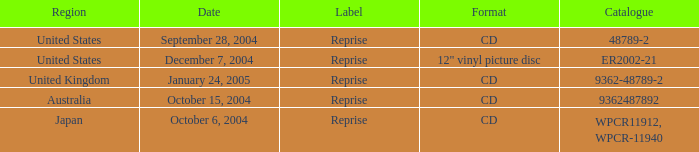Name the label for january 24, 2005 Reprise. 